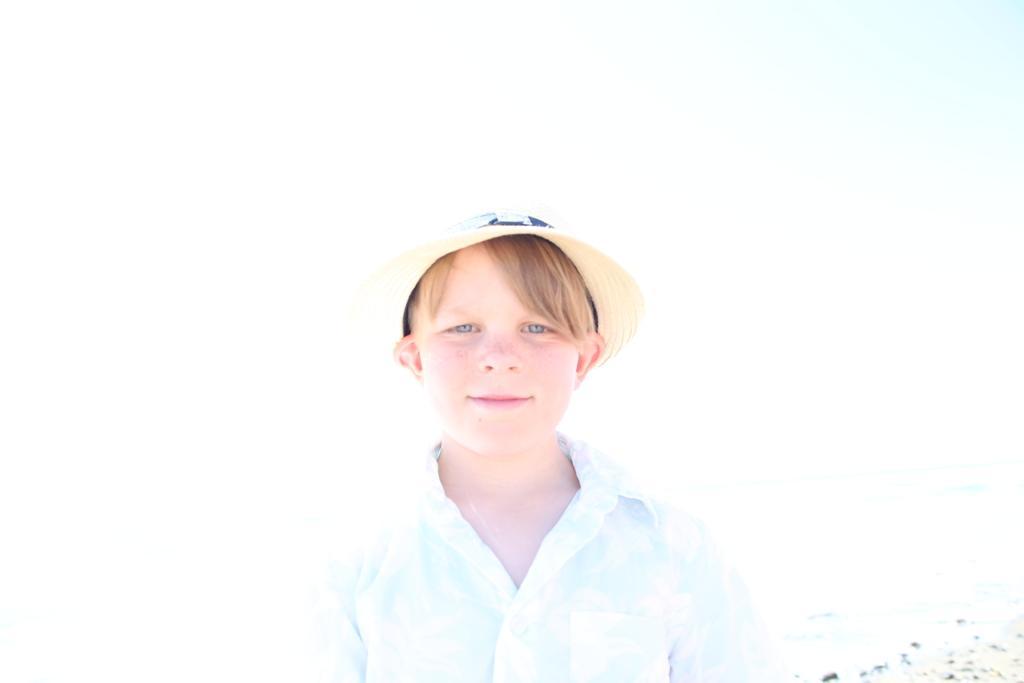Please provide a concise description of this image. In the given image i can see a boy wearing a cap. 